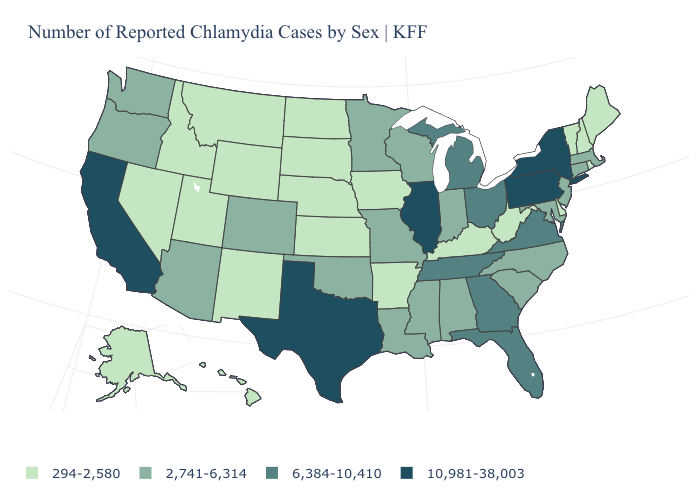What is the value of South Carolina?
Quick response, please. 2,741-6,314. What is the value of Alabama?
Be succinct. 2,741-6,314. Does the first symbol in the legend represent the smallest category?
Keep it brief. Yes. How many symbols are there in the legend?
Be succinct. 4. Which states hav the highest value in the Northeast?
Write a very short answer. New York, Pennsylvania. Among the states that border Indiana , which have the highest value?
Answer briefly. Illinois. What is the lowest value in the USA?
Answer briefly. 294-2,580. What is the value of Georgia?
Be succinct. 6,384-10,410. Which states have the lowest value in the MidWest?
Concise answer only. Iowa, Kansas, Nebraska, North Dakota, South Dakota. Name the states that have a value in the range 10,981-38,003?
Give a very brief answer. California, Illinois, New York, Pennsylvania, Texas. What is the lowest value in the USA?
Answer briefly. 294-2,580. Does the first symbol in the legend represent the smallest category?
Concise answer only. Yes. Name the states that have a value in the range 10,981-38,003?
Concise answer only. California, Illinois, New York, Pennsylvania, Texas. Does South Dakota have the highest value in the USA?
Give a very brief answer. No. What is the lowest value in the Northeast?
Keep it brief. 294-2,580. 